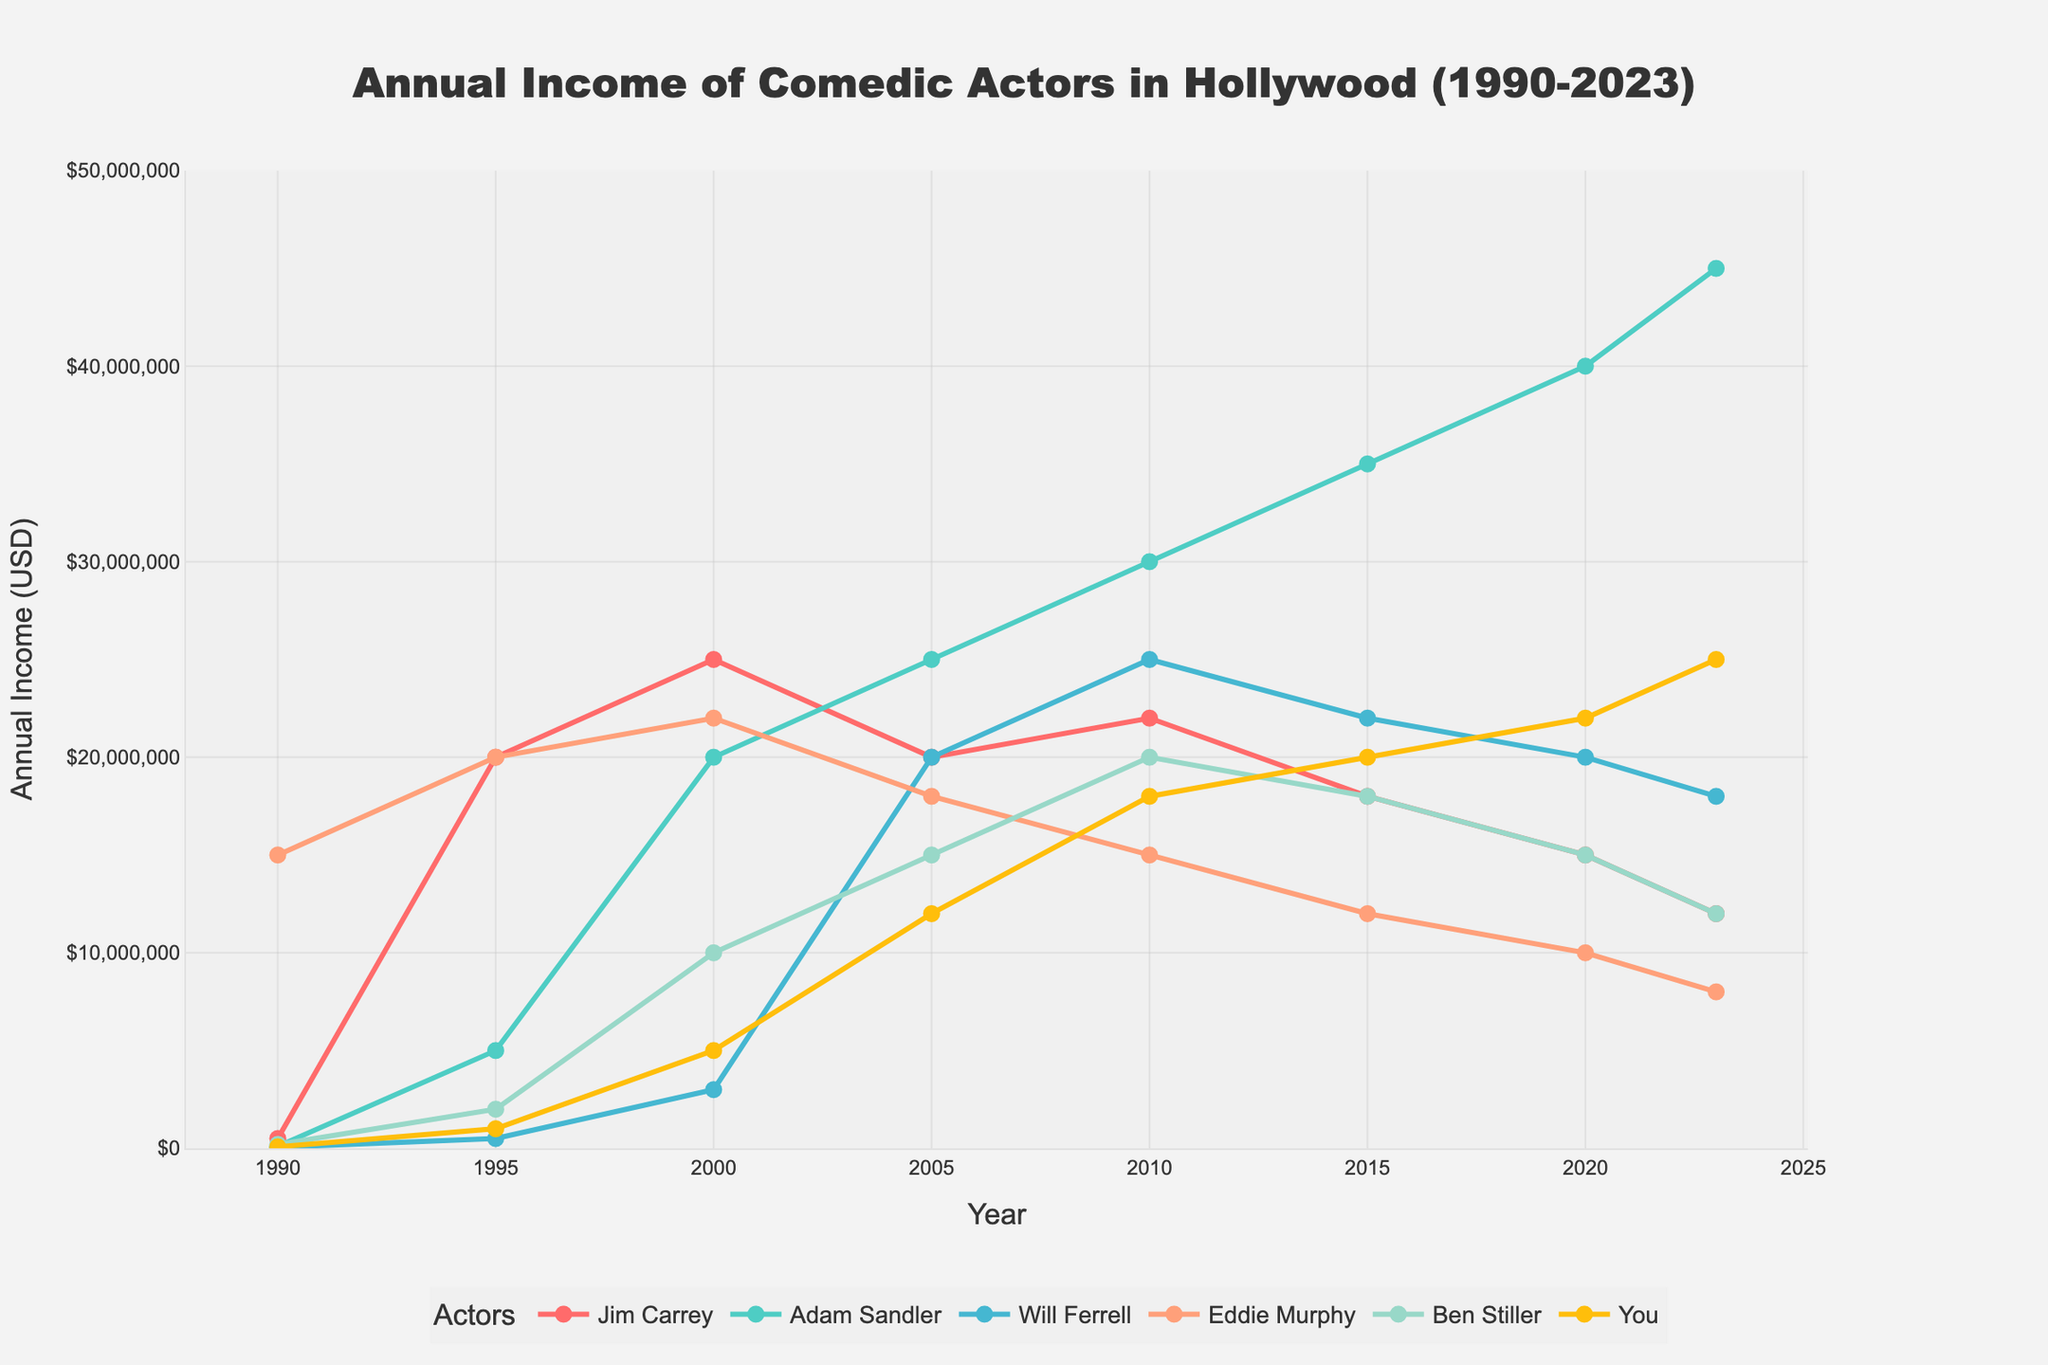What is the trend in Jim Carrey's income from 1990 to 2023? Jim Carrey's income shows a sharp rise from 1990 to 1995, peaking in 2000, followed by a gradual decline through 2023.
Answer: Gradual decline after 2000 Who has the highest income in 2023 among the comedians? By looking at the last data point in 2023, Adam Sandler has the highest income among the comedians listed.
Answer: Adam Sandler What was the difference in income between Will Ferrell and Eddie Murphy in 2005? In 2005, Will Ferrell's income was $20,000,000 and Eddie Murphy's income was $18,000,000. The difference is $20,000,000 - $18,000,000 = $2,000,000.
Answer: $2,000,000 Which comedian had the most significant increase in income from 1990 to 1995? By observing the data from 1990 to 1995, Jim Carrey's income increased from $500,000 to $20,000,000, an increase of $19,500,000. This is the highest increase among the comedians listed.
Answer: Jim Carrey What is the average annual income of Ben Stiller from 2000 to 2023? Ben Stiller’s annual income for the years 2000, 2005, 2010, 2015, 2020, and 2023 are: $10,000,000, $15,000,000, $20,000,000, $18,000,000, $15,000,000, and $12,000,000. Sum these values to get $90,000,000, then divide by the 6 years to get the average: $90,000,000 / 6 ≈ $15,000,000.
Answer: $15,000,000 Compare the income trends of Ben Stiller and "You" between 2010 and 2023. From 2010 to 2023, Ben Stiller's income decreases from $20,000,000 to $12,000,000. In contrast, "You" have a steady increase in income from $18,000,000 in 2010 to $25,000,000 in 2023.
Answer: Ben Stiller's income decreased, "You" increased How did Eddie Murphy's income change from 2000 to 2005? In 2000, Eddie Murphy's income was $22,000,000 and in 2005 it was $18,000,000. Therefore, his income decreased by $22,000,000 - $18,000,000 = $4,000,000.
Answer: Decreased by $4,000,000 What is the sum of Jim Carrey's income over the years 1990, 1995, and 2000? Jim Carrey's income in 1990 was $500,000, in 1995 was $20,000,000, and in 2000 was $25,000,000. Sum these values: $500,000 + $20,000,000 + $25,000,000 = $45,500,000.
Answer: $45,500,000 Compare the income of Adam Sandler and Will Ferrell in 2015. In 2015, Adam Sandler’s income was $35,000,000 and Will Ferrell's income was $22,000,000. Thus, Adam Sandler's income was higher.
Answer: Adam Sandler What color is used to represent Eddie Murphy's income in the chart? The chart uses light pink color to represent Eddie Murphy's income.
Answer: Light pink 